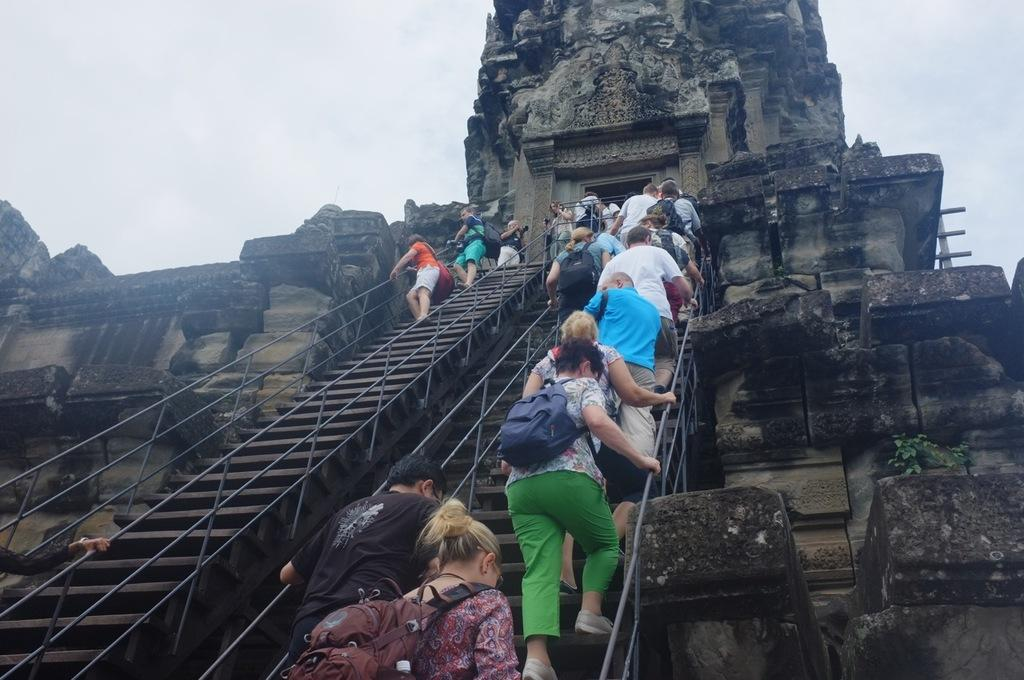What is happening in the image involving the groups of people? The people are climbing stairs in the image. What type of structure is depicted in the image? The image appears to depict a temple. What can be found on the temple in the image? The temple has sculptures. What is visible in the background of the image? The sky is visible in the image. What type of fruit can be seen in the hands of the people climbing the stairs? There is no fruit, specifically oranges, present in the image. What type of bag is being used by the people to carry their belongings while climbing the stairs? There is no bag visible in the image; the people are not carrying any bags while climbing the stairs. 